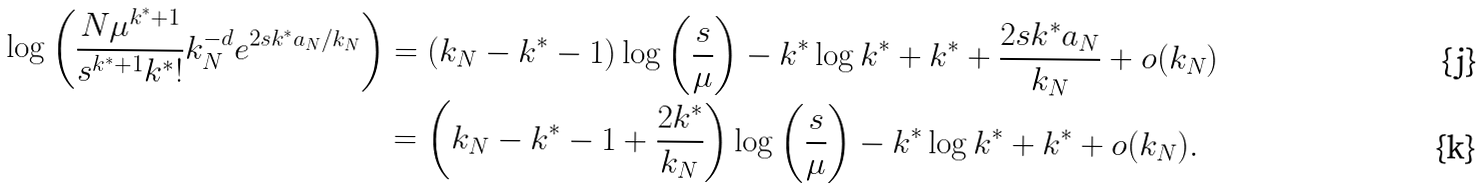<formula> <loc_0><loc_0><loc_500><loc_500>\log \left ( \frac { N \mu ^ { k ^ { * } + 1 } } { s ^ { k ^ { * } + 1 } k ^ { * } ! } k _ { N } ^ { - d } e ^ { 2 s k ^ { * } a _ { N } / k _ { N } } \right ) & = ( k _ { N } - k ^ { * } - 1 ) \log \left ( \frac { s } { \mu } \right ) - k ^ { * } \log k ^ { * } + k ^ { * } + \frac { 2 s k ^ { * } a _ { N } } { k _ { N } } + o ( k _ { N } ) \\ & = \left ( k _ { N } - k ^ { * } - 1 + \frac { 2 k ^ { * } } { k _ { N } } \right ) \log \left ( \frac { s } { \mu } \right ) - k ^ { * } \log k ^ { * } + k ^ { * } + o ( k _ { N } ) .</formula> 